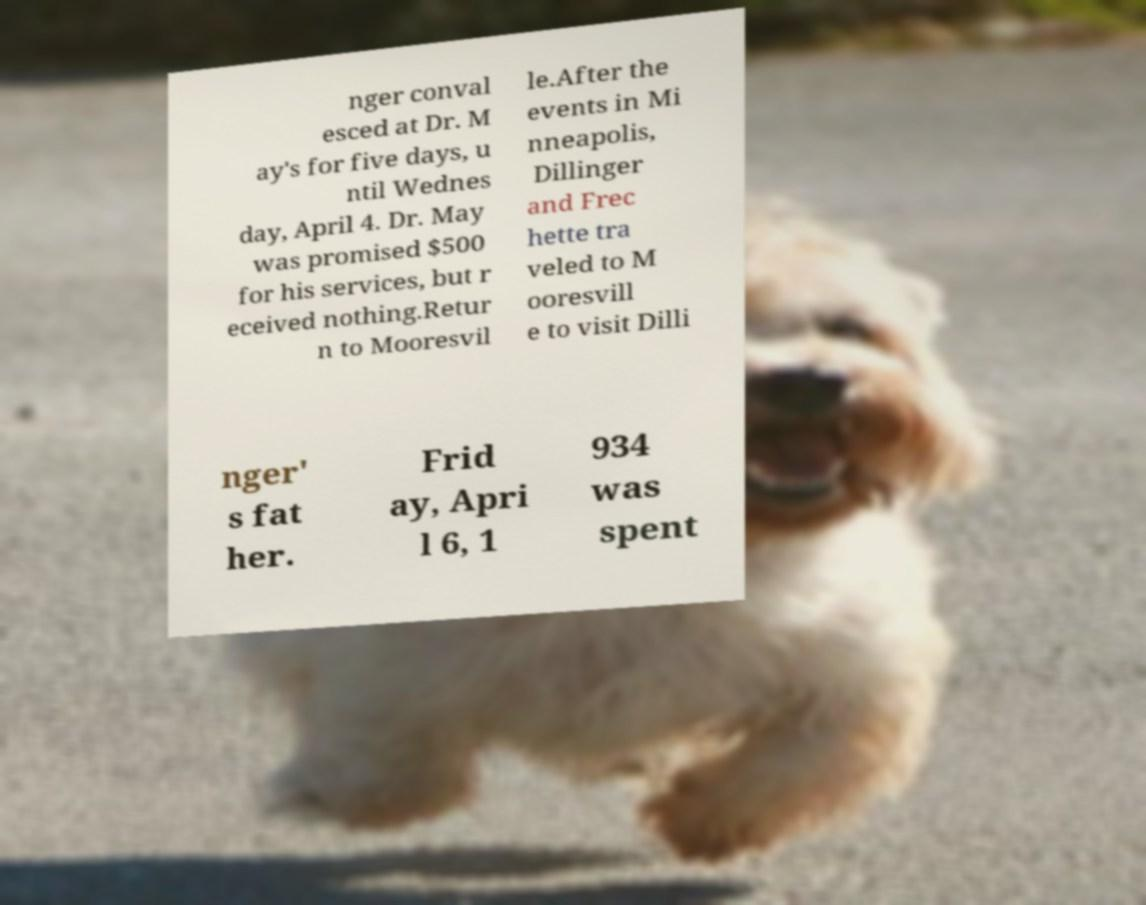There's text embedded in this image that I need extracted. Can you transcribe it verbatim? nger conval esced at Dr. M ay's for five days, u ntil Wednes day, April 4. Dr. May was promised $500 for his services, but r eceived nothing.Retur n to Mooresvil le.After the events in Mi nneapolis, Dillinger and Frec hette tra veled to M ooresvill e to visit Dilli nger' s fat her. Frid ay, Apri l 6, 1 934 was spent 